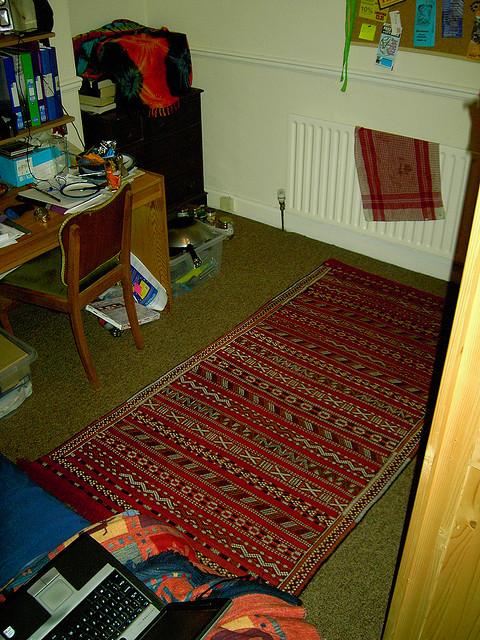What is the pattern on the border of the rug?
Quick response, please. Stripes. Is there a sewing machine in the room?
Write a very short answer. No. Is this a mirror image?
Quick response, please. No. Is this room a mess?
Be succinct. No. Is this a dorm room?
Short answer required. Yes. Does the woman have a pet?
Give a very brief answer. No. 